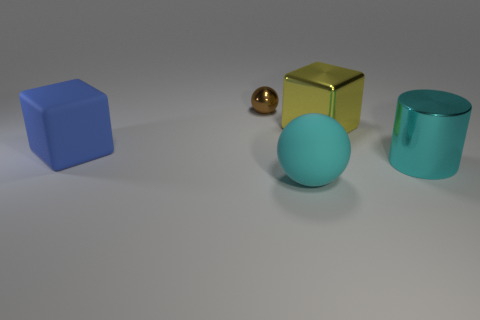What materials are the objects made of, and how can you tell? The objects appear to have different materials. The blue and turquoise objects exhibit a matte finish consistent with plastic or painted surfaces. The golden cube has a reflective surface suggesting it could be made from a polished metal or have a metallic paint finish. The small sphere in the center seems to be a different type of metal, as indicated by its lustrous but less reflective surface. 